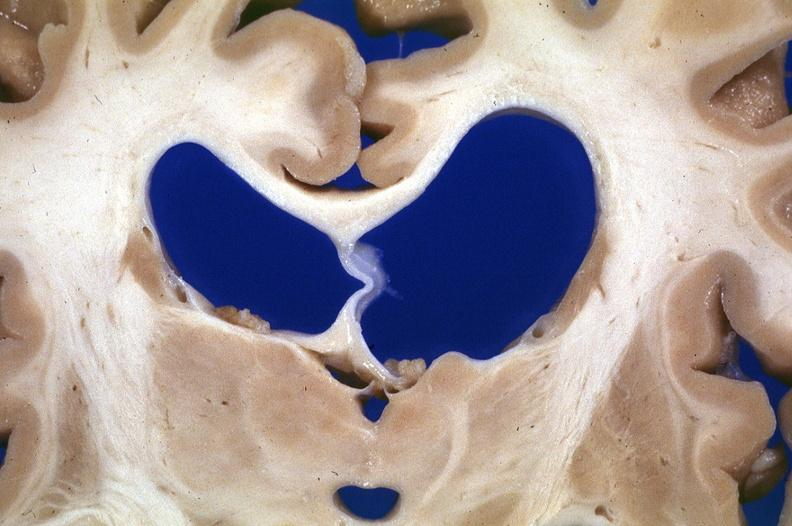s hypertrophic gastritis present?
Answer the question using a single word or phrase. No 